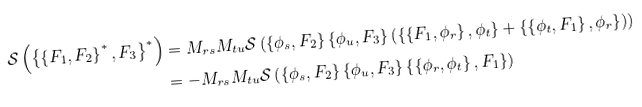Convert formula to latex. <formula><loc_0><loc_0><loc_500><loc_500>\mathcal { S } \left ( \left \{ { \left \{ { F _ { 1 } , F _ { 2 } } \right \} ^ { * } , F _ { 3 } } \right \} ^ { * } \right ) & = M _ { r s } M _ { t u } \mathcal { S } \left ( { \left \{ { \phi _ { s } , F _ { 2 } } \right \} \left \{ { \phi _ { u } , F _ { 3 } } \right \} \left ( { \left \{ { \left \{ { F _ { 1 } , \phi _ { r } } \right \} , \phi _ { t } } \right \} + \left \{ { \left \{ { \phi _ { t } , F _ { 1 } } \right \} , \phi _ { r } } \right \} } \right ) } \right ) \\ & = - M _ { r s } M _ { t u } \mathcal { S } \left ( { \left \{ { \phi _ { s } , F _ { 2 } } \right \} \left \{ { \phi _ { u } , F _ { 3 } } \right \} \left \{ { \left \{ { \phi _ { r } , \phi _ { t } } \right \} , F _ { 1 } } \right \} } \right )</formula> 